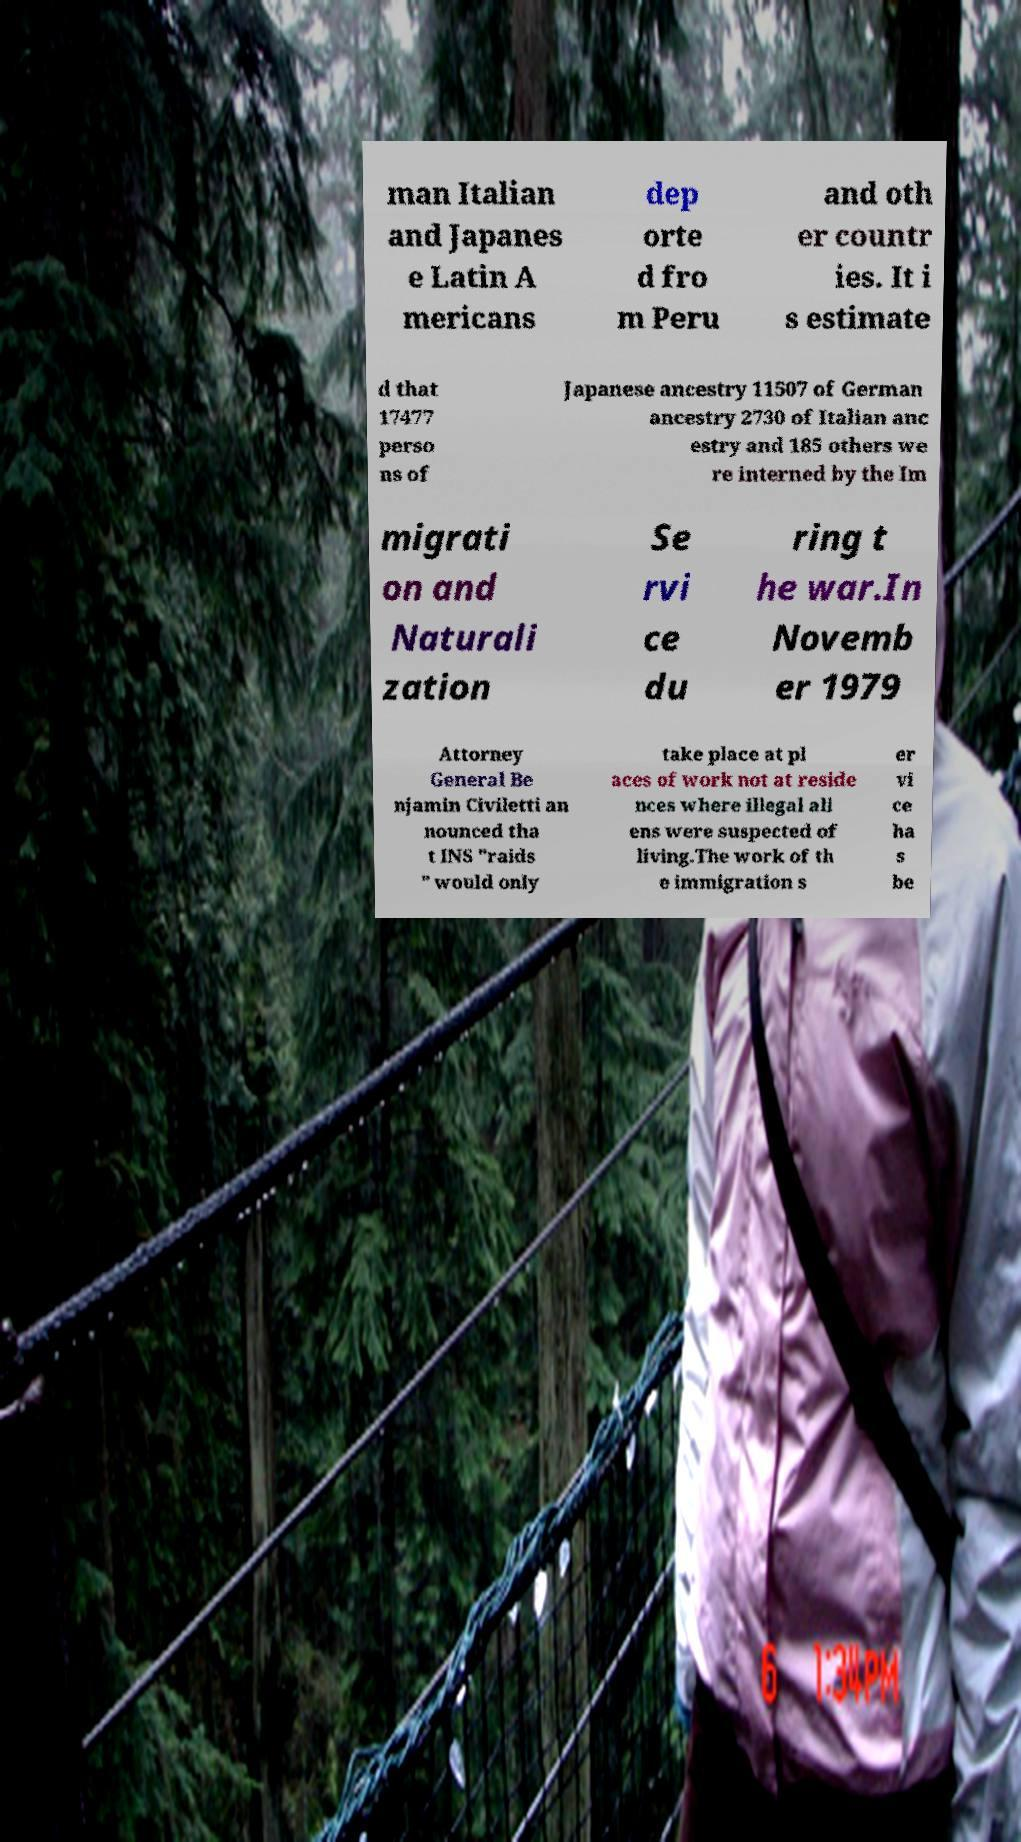Could you extract and type out the text from this image? man Italian and Japanes e Latin A mericans dep orte d fro m Peru and oth er countr ies. It i s estimate d that 17477 perso ns of Japanese ancestry 11507 of German ancestry 2730 of Italian anc estry and 185 others we re interned by the Im migrati on and Naturali zation Se rvi ce du ring t he war.In Novemb er 1979 Attorney General Be njamin Civiletti an nounced tha t INS "raids " would only take place at pl aces of work not at reside nces where illegal ali ens were suspected of living.The work of th e immigration s er vi ce ha s be 